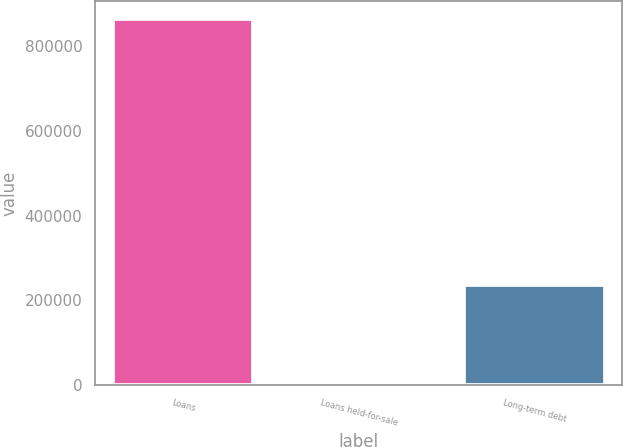Convert chart. <chart><loc_0><loc_0><loc_500><loc_500><bar_chart><fcel>Loans<fcel>Loans held-for-sale<fcel>Long-term debt<nl><fcel>863561<fcel>7453<fcel>236764<nl></chart> 